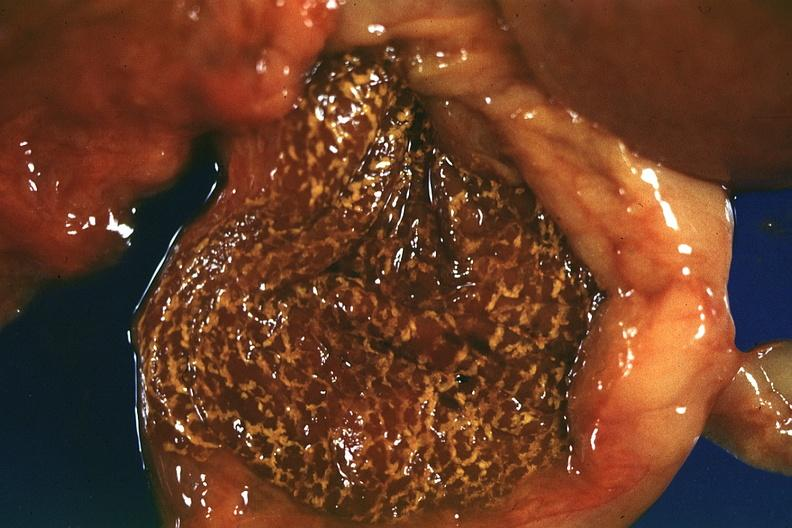what does this image show?
Answer the question using a single word or phrase. Fresh tissue but rather autolyzed appearance 